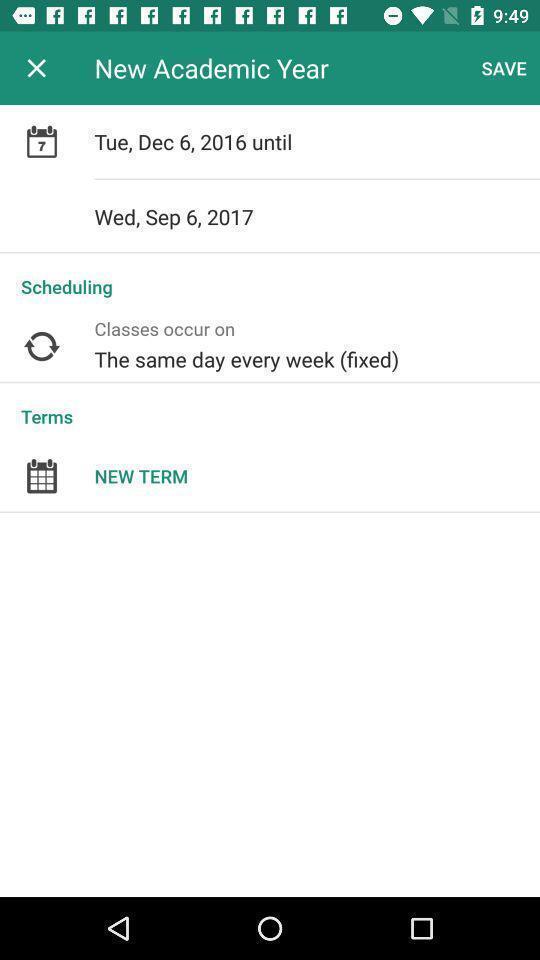Explain what's happening in this screen capture. Screen asking to set new academic year. 